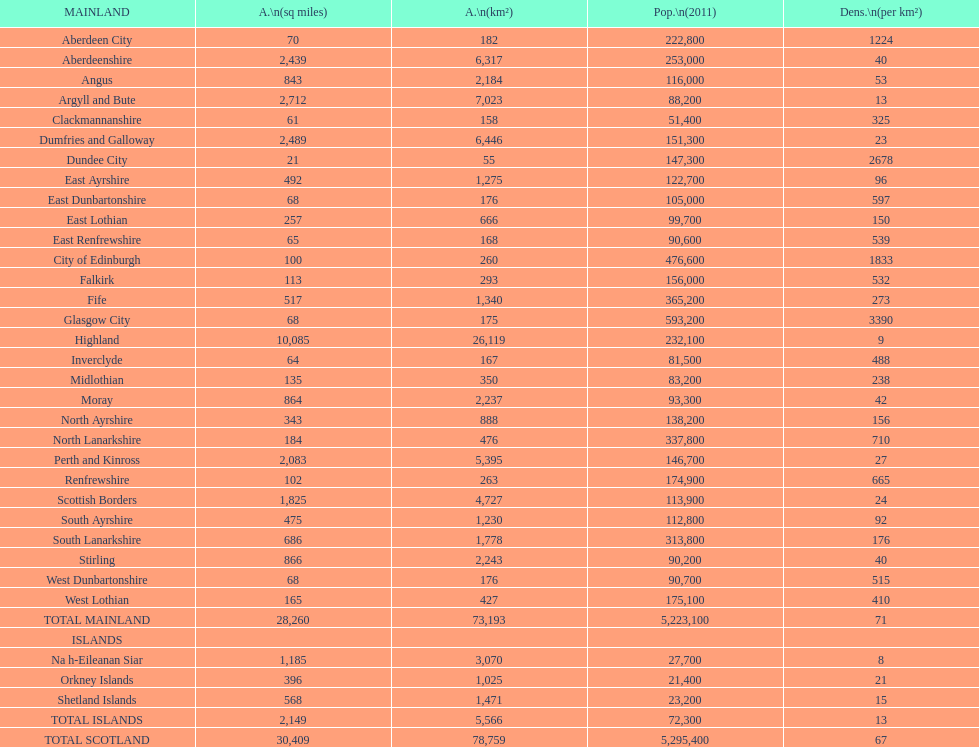If you were to sort the locations from the tiniest to biggest area, which one would be at the beginning of the list? Dundee City. 